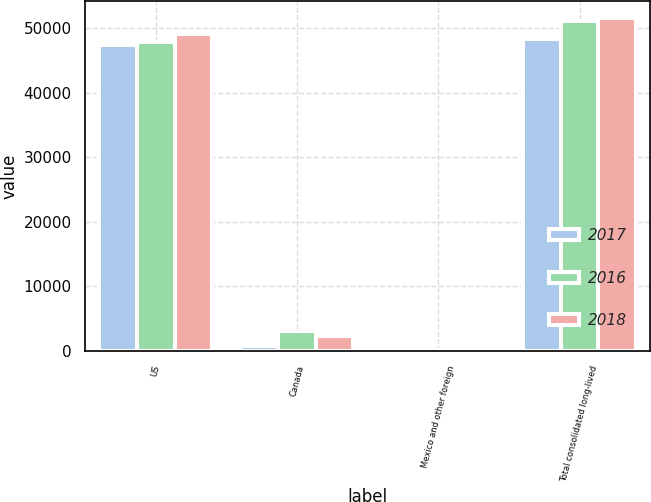Convert chart to OTSL. <chart><loc_0><loc_0><loc_500><loc_500><stacked_bar_chart><ecel><fcel>US<fcel>Canada<fcel>Mexico and other foreign<fcel>Total consolidated long-lived<nl><fcel>2017<fcel>47468<fcel>748<fcel>83<fcel>48299<nl><fcel>2016<fcel>47928<fcel>3071<fcel>80<fcel>51079<nl><fcel>2018<fcel>49125<fcel>2399<fcel>82<fcel>51606<nl></chart> 